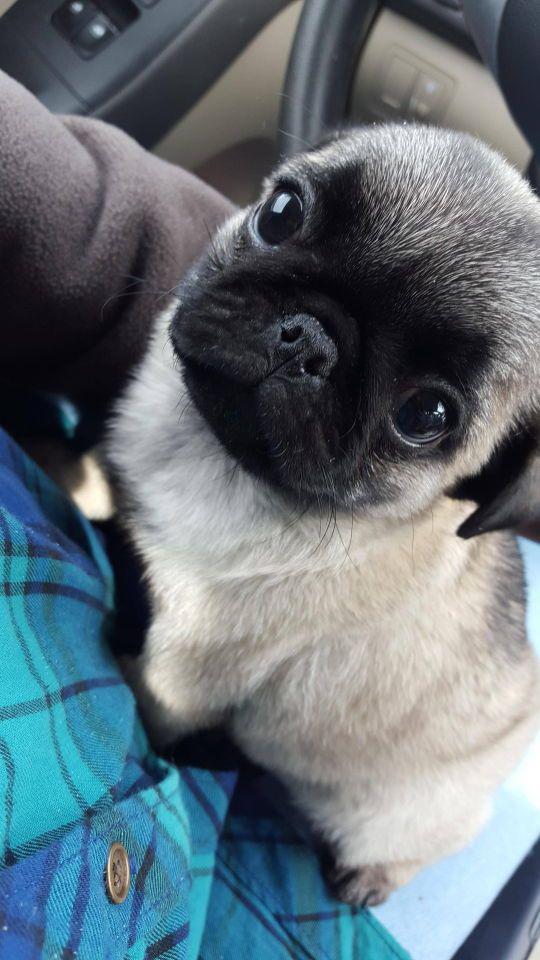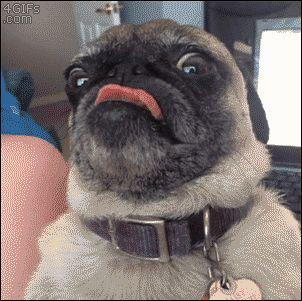The first image is the image on the left, the second image is the image on the right. Considering the images on both sides, is "Each image features one camera-gazing buff-beige pug with a dark muzzle, and one pug has its tongue sticking out." valid? Answer yes or no. Yes. The first image is the image on the left, the second image is the image on the right. Evaluate the accuracy of this statement regarding the images: "Both images show a single pug and in one it has its tongue sticking out.". Is it true? Answer yes or no. Yes. 